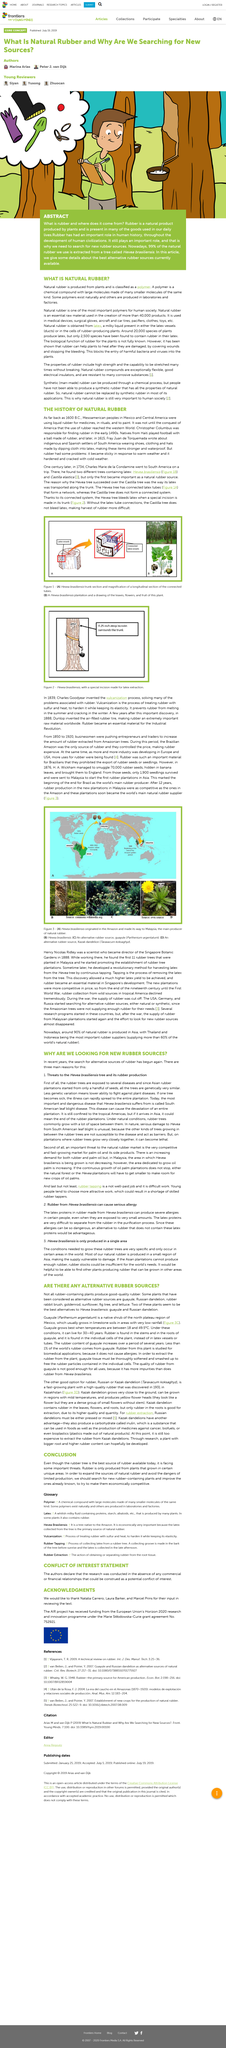Mention a couple of crucial points in this snapshot. Rubber alternatives, such as guayule and Russian dandelion, are two sources that provide excellent alternatives to rubber. After 12 years, Malaysia emerged as the leading provider of natural rubber to the world. Hevea brasiliensis and Castilla elastica are the species of trees that produce latex. During the period of 1850 to 1920, the Brazilian Amazon was the only source of rubber. The Russian dandelion is known for its root, which is highly valued in the rubber extraction industry. 